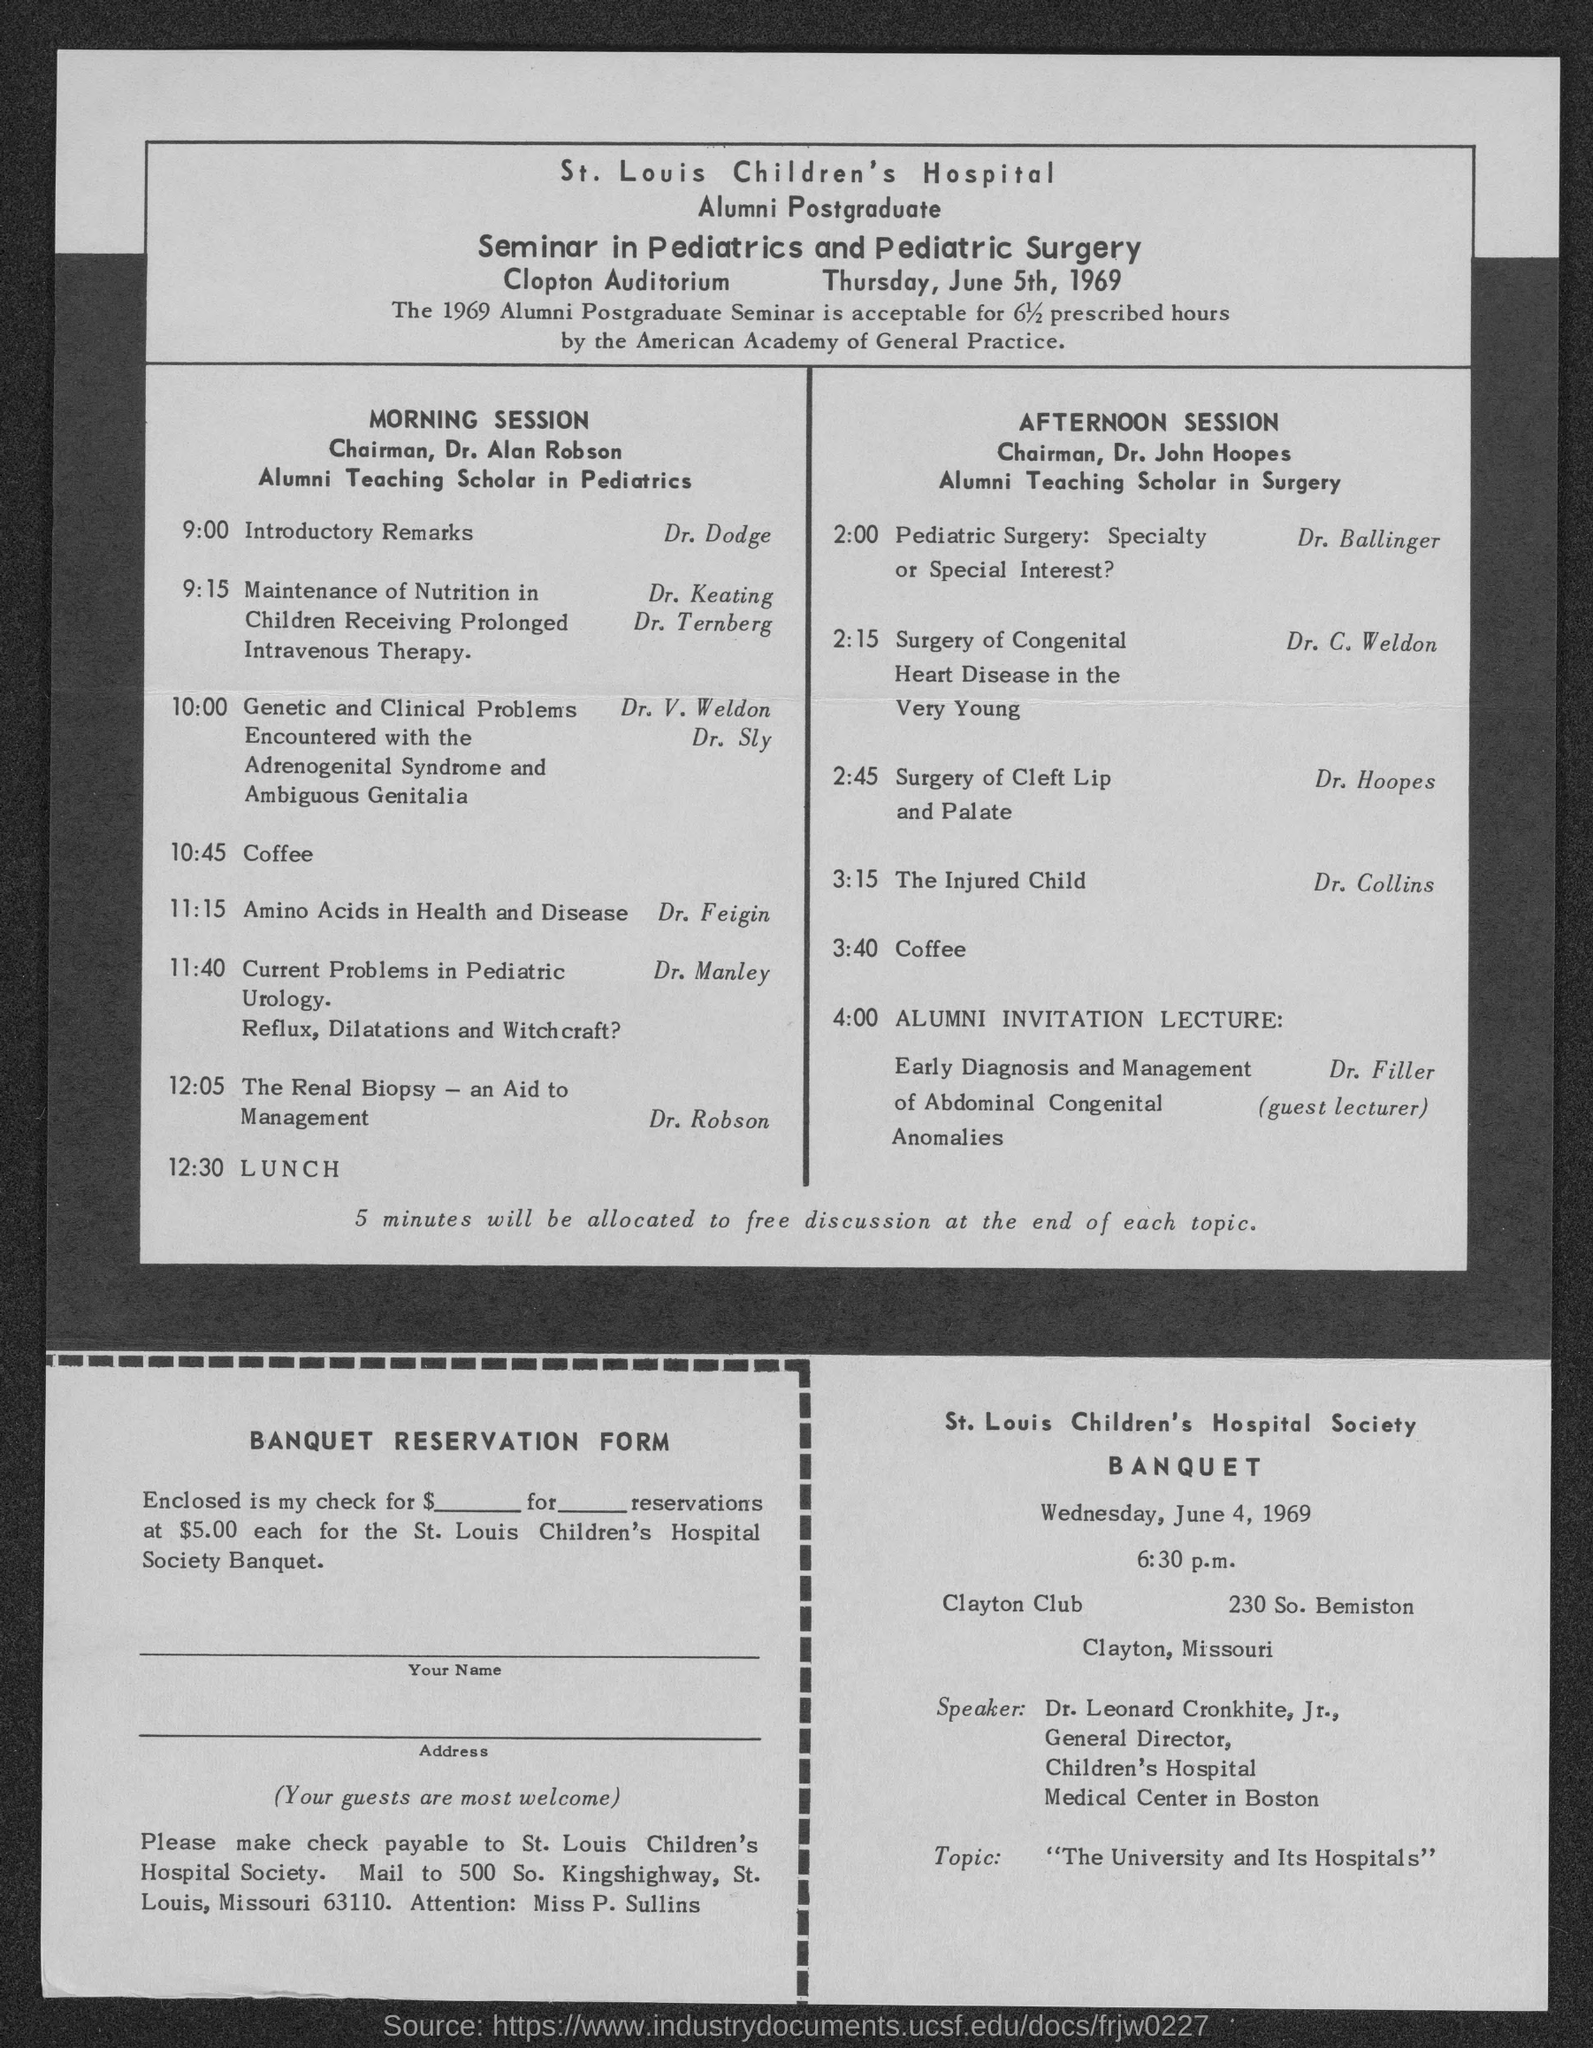List a handful of essential elements in this visual. The Chairman for the morning session is Dr. Alan Robson. The topic of Dr. Feigin is amino acids in health and disease. The St. Louis Children's Hospital is mentioned. Dr. Hoopes is the speaker who is discussing the topic of surgery for cleft lip and palate. It is Dr. Dodge who is giving the introductory remarks. 